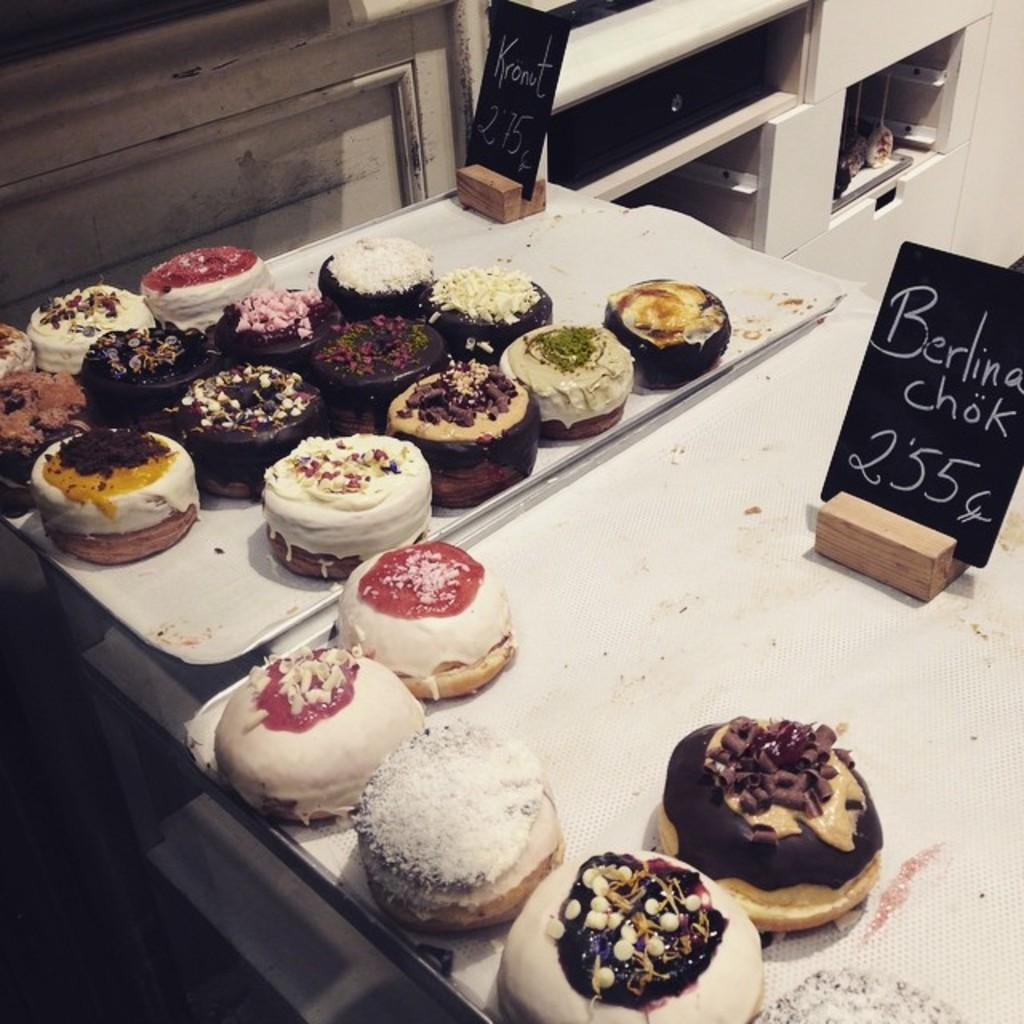What type of food is on the tray in the image? There are cakes placed on a tray in the image. What decoration can be seen on the cakes? The cakes have sprinkles on them. How can the price of the cakes be determined? There are price tags on the tray. What can be seen in the background of the image? There are shelves in the background of the image. What is the chance of winning a trip to the moon in the image? There is no mention of a chance to win a trip to the moon in the image; it features cakes on a tray with price tags. 